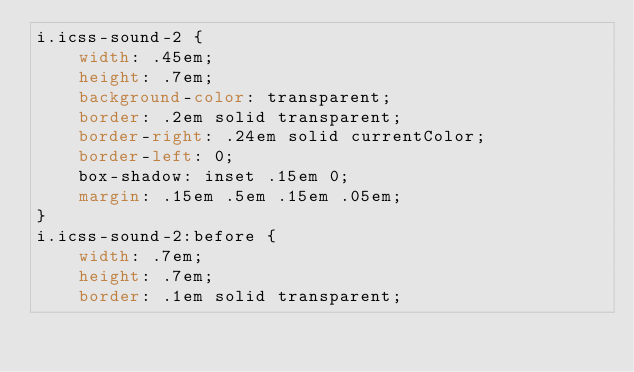Convert code to text. <code><loc_0><loc_0><loc_500><loc_500><_CSS_>i.icss-sound-2 {
    width: .45em;
    height: .7em;
    background-color: transparent;
    border: .2em solid transparent;
    border-right: .24em solid currentColor; 
    border-left: 0;
    box-shadow: inset .15em 0;
    margin: .15em .5em .15em .05em;
}
i.icss-sound-2:before {
    width: .7em;
    height: .7em;
    border: .1em solid transparent;</code> 